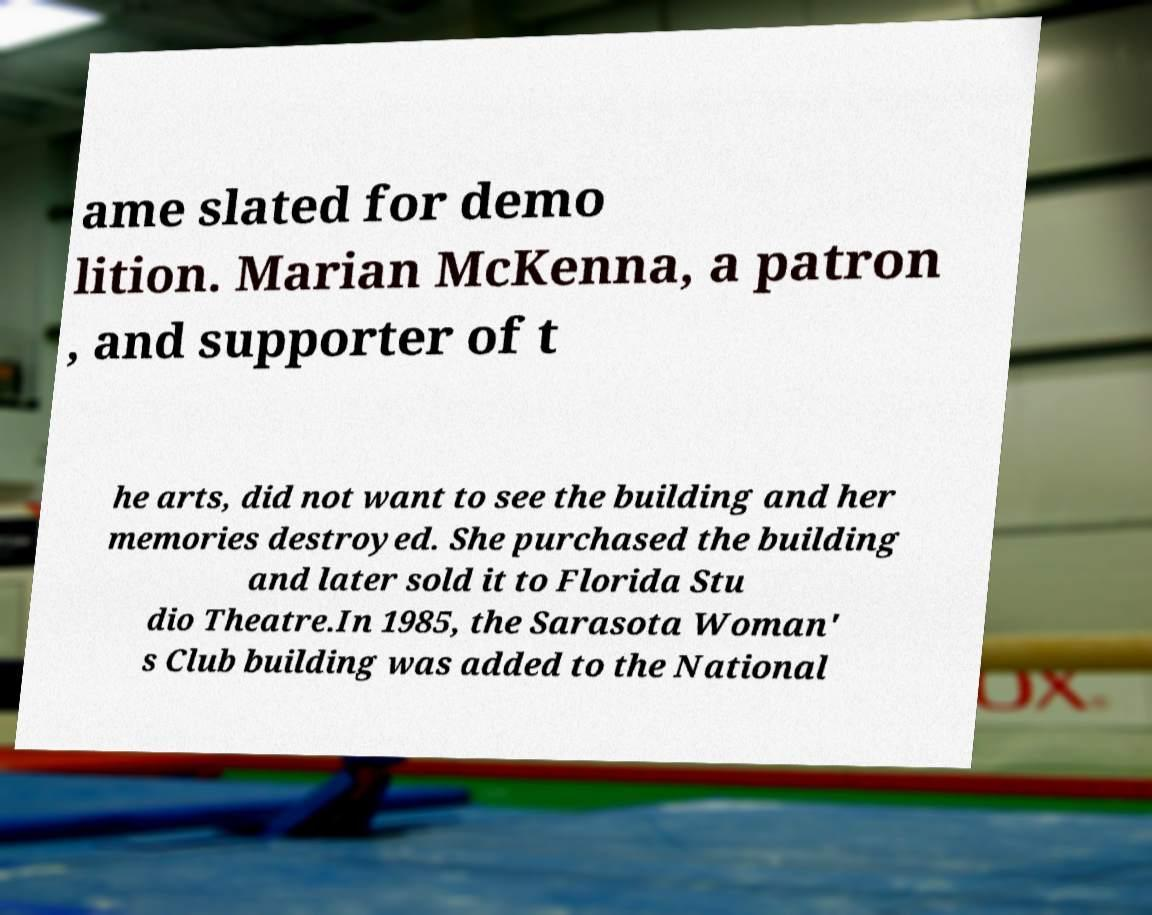Could you extract and type out the text from this image? ame slated for demo lition. Marian McKenna, a patron , and supporter of t he arts, did not want to see the building and her memories destroyed. She purchased the building and later sold it to Florida Stu dio Theatre.In 1985, the Sarasota Woman' s Club building was added to the National 